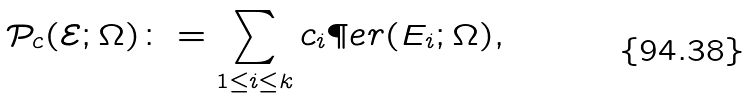Convert formula to latex. <formula><loc_0><loc_0><loc_500><loc_500>\mathcal { P } _ { c } ( \mathcal { E } ; \Omega ) \colon = \sum _ { 1 \leq i \leq k } c _ { i } \P e r ( E _ { i } ; \Omega ) ,</formula> 